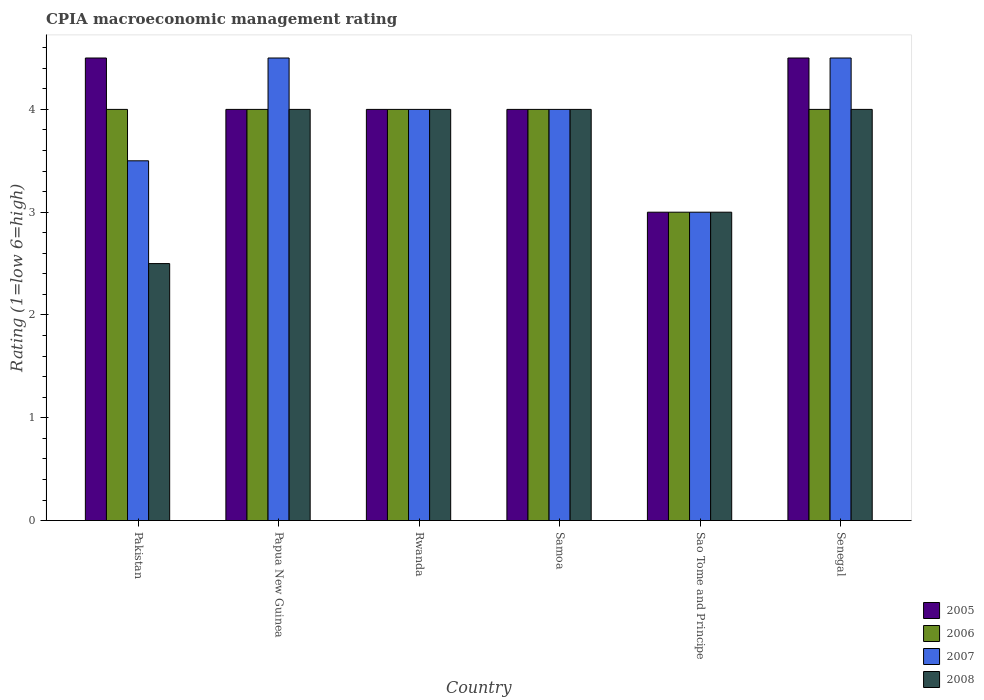Are the number of bars on each tick of the X-axis equal?
Provide a short and direct response. Yes. What is the label of the 4th group of bars from the left?
Your answer should be very brief. Samoa. In which country was the CPIA rating in 2008 maximum?
Ensure brevity in your answer.  Papua New Guinea. In which country was the CPIA rating in 2005 minimum?
Your answer should be compact. Sao Tome and Principe. What is the difference between the CPIA rating in 2005 in Rwanda and that in Senegal?
Keep it short and to the point. -0.5. What is the average CPIA rating in 2007 per country?
Offer a very short reply. 3.92. In how many countries, is the CPIA rating in 2007 greater than 3.2?
Your response must be concise. 5. What is the ratio of the CPIA rating in 2007 in Pakistan to that in Senegal?
Ensure brevity in your answer.  0.78. Is the difference between the CPIA rating in 2007 in Rwanda and Samoa greater than the difference between the CPIA rating in 2006 in Rwanda and Samoa?
Give a very brief answer. No. What is the difference between the highest and the second highest CPIA rating in 2005?
Provide a succinct answer. 0.5. What is the difference between the highest and the lowest CPIA rating in 2005?
Give a very brief answer. 1.5. In how many countries, is the CPIA rating in 2008 greater than the average CPIA rating in 2008 taken over all countries?
Your answer should be very brief. 4. Is it the case that in every country, the sum of the CPIA rating in 2005 and CPIA rating in 2008 is greater than the sum of CPIA rating in 2006 and CPIA rating in 2007?
Offer a terse response. No. What does the 3rd bar from the left in Rwanda represents?
Offer a terse response. 2007. Is it the case that in every country, the sum of the CPIA rating in 2006 and CPIA rating in 2007 is greater than the CPIA rating in 2005?
Offer a terse response. Yes. Are all the bars in the graph horizontal?
Your response must be concise. No. Does the graph contain grids?
Keep it short and to the point. No. How are the legend labels stacked?
Ensure brevity in your answer.  Vertical. What is the title of the graph?
Offer a terse response. CPIA macroeconomic management rating. Does "1985" appear as one of the legend labels in the graph?
Offer a terse response. No. What is the label or title of the X-axis?
Offer a very short reply. Country. What is the Rating (1=low 6=high) of 2006 in Pakistan?
Make the answer very short. 4. What is the Rating (1=low 6=high) in 2006 in Papua New Guinea?
Keep it short and to the point. 4. What is the Rating (1=low 6=high) of 2007 in Papua New Guinea?
Provide a short and direct response. 4.5. What is the Rating (1=low 6=high) in 2008 in Papua New Guinea?
Provide a short and direct response. 4. What is the Rating (1=low 6=high) of 2005 in Rwanda?
Your response must be concise. 4. What is the Rating (1=low 6=high) in 2008 in Rwanda?
Your response must be concise. 4. What is the Rating (1=low 6=high) of 2006 in Samoa?
Your response must be concise. 4. What is the Rating (1=low 6=high) of 2008 in Samoa?
Your response must be concise. 4. What is the Rating (1=low 6=high) in 2006 in Sao Tome and Principe?
Your response must be concise. 3. What is the Rating (1=low 6=high) of 2008 in Sao Tome and Principe?
Offer a terse response. 3. What is the Rating (1=low 6=high) in 2005 in Senegal?
Offer a terse response. 4.5. What is the Rating (1=low 6=high) in 2007 in Senegal?
Make the answer very short. 4.5. What is the Rating (1=low 6=high) of 2008 in Senegal?
Your answer should be compact. 4. Across all countries, what is the maximum Rating (1=low 6=high) in 2007?
Give a very brief answer. 4.5. Across all countries, what is the minimum Rating (1=low 6=high) of 2005?
Your answer should be compact. 3. Across all countries, what is the minimum Rating (1=low 6=high) of 2006?
Provide a short and direct response. 3. What is the total Rating (1=low 6=high) in 2006 in the graph?
Ensure brevity in your answer.  23. What is the total Rating (1=low 6=high) of 2007 in the graph?
Keep it short and to the point. 23.5. What is the total Rating (1=low 6=high) in 2008 in the graph?
Your response must be concise. 21.5. What is the difference between the Rating (1=low 6=high) in 2006 in Pakistan and that in Papua New Guinea?
Your answer should be compact. 0. What is the difference between the Rating (1=low 6=high) in 2007 in Pakistan and that in Papua New Guinea?
Your answer should be compact. -1. What is the difference between the Rating (1=low 6=high) in 2005 in Pakistan and that in Rwanda?
Provide a succinct answer. 0.5. What is the difference between the Rating (1=low 6=high) in 2005 in Pakistan and that in Samoa?
Ensure brevity in your answer.  0.5. What is the difference between the Rating (1=low 6=high) in 2007 in Pakistan and that in Samoa?
Offer a very short reply. -0.5. What is the difference between the Rating (1=low 6=high) of 2005 in Pakistan and that in Sao Tome and Principe?
Your answer should be compact. 1.5. What is the difference between the Rating (1=low 6=high) of 2007 in Pakistan and that in Sao Tome and Principe?
Your answer should be compact. 0.5. What is the difference between the Rating (1=low 6=high) of 2007 in Pakistan and that in Senegal?
Offer a terse response. -1. What is the difference between the Rating (1=low 6=high) in 2008 in Pakistan and that in Senegal?
Your answer should be very brief. -1.5. What is the difference between the Rating (1=low 6=high) in 2005 in Papua New Guinea and that in Rwanda?
Offer a terse response. 0. What is the difference between the Rating (1=low 6=high) of 2007 in Papua New Guinea and that in Rwanda?
Provide a short and direct response. 0.5. What is the difference between the Rating (1=low 6=high) of 2008 in Papua New Guinea and that in Rwanda?
Provide a short and direct response. 0. What is the difference between the Rating (1=low 6=high) of 2005 in Papua New Guinea and that in Samoa?
Make the answer very short. 0. What is the difference between the Rating (1=low 6=high) of 2006 in Papua New Guinea and that in Sao Tome and Principe?
Provide a succinct answer. 1. What is the difference between the Rating (1=low 6=high) of 2007 in Papua New Guinea and that in Sao Tome and Principe?
Your response must be concise. 1.5. What is the difference between the Rating (1=low 6=high) in 2008 in Papua New Guinea and that in Sao Tome and Principe?
Give a very brief answer. 1. What is the difference between the Rating (1=low 6=high) in 2006 in Papua New Guinea and that in Senegal?
Provide a succinct answer. 0. What is the difference between the Rating (1=low 6=high) in 2008 in Papua New Guinea and that in Senegal?
Your answer should be compact. 0. What is the difference between the Rating (1=low 6=high) in 2005 in Rwanda and that in Samoa?
Ensure brevity in your answer.  0. What is the difference between the Rating (1=low 6=high) of 2006 in Rwanda and that in Samoa?
Ensure brevity in your answer.  0. What is the difference between the Rating (1=low 6=high) of 2007 in Rwanda and that in Samoa?
Your answer should be very brief. 0. What is the difference between the Rating (1=low 6=high) of 2005 in Rwanda and that in Sao Tome and Principe?
Provide a short and direct response. 1. What is the difference between the Rating (1=low 6=high) in 2005 in Rwanda and that in Senegal?
Ensure brevity in your answer.  -0.5. What is the difference between the Rating (1=low 6=high) of 2007 in Rwanda and that in Senegal?
Give a very brief answer. -0.5. What is the difference between the Rating (1=low 6=high) in 2006 in Samoa and that in Sao Tome and Principe?
Give a very brief answer. 1. What is the difference between the Rating (1=low 6=high) of 2008 in Samoa and that in Sao Tome and Principe?
Offer a very short reply. 1. What is the difference between the Rating (1=low 6=high) in 2006 in Samoa and that in Senegal?
Your answer should be very brief. 0. What is the difference between the Rating (1=low 6=high) of 2007 in Samoa and that in Senegal?
Provide a short and direct response. -0.5. What is the difference between the Rating (1=low 6=high) of 2006 in Sao Tome and Principe and that in Senegal?
Offer a terse response. -1. What is the difference between the Rating (1=low 6=high) of 2007 in Sao Tome and Principe and that in Senegal?
Offer a very short reply. -1.5. What is the difference between the Rating (1=low 6=high) of 2005 in Pakistan and the Rating (1=low 6=high) of 2008 in Papua New Guinea?
Keep it short and to the point. 0.5. What is the difference between the Rating (1=low 6=high) of 2005 in Pakistan and the Rating (1=low 6=high) of 2008 in Rwanda?
Make the answer very short. 0.5. What is the difference between the Rating (1=low 6=high) of 2006 in Pakistan and the Rating (1=low 6=high) of 2007 in Rwanda?
Ensure brevity in your answer.  0. What is the difference between the Rating (1=low 6=high) in 2006 in Pakistan and the Rating (1=low 6=high) in 2008 in Rwanda?
Provide a short and direct response. 0. What is the difference between the Rating (1=low 6=high) in 2005 in Pakistan and the Rating (1=low 6=high) in 2006 in Samoa?
Make the answer very short. 0.5. What is the difference between the Rating (1=low 6=high) in 2006 in Pakistan and the Rating (1=low 6=high) in 2007 in Samoa?
Offer a terse response. 0. What is the difference between the Rating (1=low 6=high) of 2006 in Pakistan and the Rating (1=low 6=high) of 2008 in Samoa?
Provide a short and direct response. 0. What is the difference between the Rating (1=low 6=high) in 2007 in Pakistan and the Rating (1=low 6=high) in 2008 in Samoa?
Provide a succinct answer. -0.5. What is the difference between the Rating (1=low 6=high) of 2005 in Pakistan and the Rating (1=low 6=high) of 2007 in Sao Tome and Principe?
Your response must be concise. 1.5. What is the difference between the Rating (1=low 6=high) in 2006 in Pakistan and the Rating (1=low 6=high) in 2007 in Sao Tome and Principe?
Offer a terse response. 1. What is the difference between the Rating (1=low 6=high) of 2005 in Pakistan and the Rating (1=low 6=high) of 2006 in Senegal?
Your response must be concise. 0.5. What is the difference between the Rating (1=low 6=high) in 2005 in Pakistan and the Rating (1=low 6=high) in 2007 in Senegal?
Keep it short and to the point. 0. What is the difference between the Rating (1=low 6=high) of 2006 in Pakistan and the Rating (1=low 6=high) of 2007 in Senegal?
Ensure brevity in your answer.  -0.5. What is the difference between the Rating (1=low 6=high) in 2006 in Pakistan and the Rating (1=low 6=high) in 2008 in Senegal?
Keep it short and to the point. 0. What is the difference between the Rating (1=low 6=high) of 2005 in Papua New Guinea and the Rating (1=low 6=high) of 2007 in Rwanda?
Your answer should be compact. 0. What is the difference between the Rating (1=low 6=high) of 2007 in Papua New Guinea and the Rating (1=low 6=high) of 2008 in Rwanda?
Ensure brevity in your answer.  0.5. What is the difference between the Rating (1=low 6=high) in 2007 in Papua New Guinea and the Rating (1=low 6=high) in 2008 in Samoa?
Ensure brevity in your answer.  0.5. What is the difference between the Rating (1=low 6=high) in 2005 in Papua New Guinea and the Rating (1=low 6=high) in 2008 in Sao Tome and Principe?
Ensure brevity in your answer.  1. What is the difference between the Rating (1=low 6=high) in 2006 in Papua New Guinea and the Rating (1=low 6=high) in 2007 in Sao Tome and Principe?
Give a very brief answer. 1. What is the difference between the Rating (1=low 6=high) of 2006 in Papua New Guinea and the Rating (1=low 6=high) of 2008 in Sao Tome and Principe?
Keep it short and to the point. 1. What is the difference between the Rating (1=low 6=high) of 2007 in Papua New Guinea and the Rating (1=low 6=high) of 2008 in Sao Tome and Principe?
Offer a terse response. 1.5. What is the difference between the Rating (1=low 6=high) of 2005 in Papua New Guinea and the Rating (1=low 6=high) of 2006 in Senegal?
Offer a terse response. 0. What is the difference between the Rating (1=low 6=high) of 2005 in Papua New Guinea and the Rating (1=low 6=high) of 2008 in Senegal?
Ensure brevity in your answer.  0. What is the difference between the Rating (1=low 6=high) of 2007 in Papua New Guinea and the Rating (1=low 6=high) of 2008 in Senegal?
Offer a very short reply. 0.5. What is the difference between the Rating (1=low 6=high) of 2006 in Rwanda and the Rating (1=low 6=high) of 2007 in Samoa?
Provide a short and direct response. 0. What is the difference between the Rating (1=low 6=high) of 2006 in Rwanda and the Rating (1=low 6=high) of 2008 in Samoa?
Provide a succinct answer. 0. What is the difference between the Rating (1=low 6=high) in 2007 in Rwanda and the Rating (1=low 6=high) in 2008 in Samoa?
Ensure brevity in your answer.  0. What is the difference between the Rating (1=low 6=high) in 2005 in Rwanda and the Rating (1=low 6=high) in 2007 in Senegal?
Give a very brief answer. -0.5. What is the difference between the Rating (1=low 6=high) of 2005 in Rwanda and the Rating (1=low 6=high) of 2008 in Senegal?
Give a very brief answer. 0. What is the difference between the Rating (1=low 6=high) in 2006 in Rwanda and the Rating (1=low 6=high) in 2008 in Senegal?
Your answer should be compact. 0. What is the difference between the Rating (1=low 6=high) of 2007 in Rwanda and the Rating (1=low 6=high) of 2008 in Senegal?
Offer a very short reply. 0. What is the difference between the Rating (1=low 6=high) in 2005 in Samoa and the Rating (1=low 6=high) in 2006 in Sao Tome and Principe?
Offer a very short reply. 1. What is the difference between the Rating (1=low 6=high) in 2006 in Samoa and the Rating (1=low 6=high) in 2008 in Sao Tome and Principe?
Keep it short and to the point. 1. What is the difference between the Rating (1=low 6=high) of 2005 in Samoa and the Rating (1=low 6=high) of 2007 in Senegal?
Your answer should be compact. -0.5. What is the difference between the Rating (1=low 6=high) in 2006 in Samoa and the Rating (1=low 6=high) in 2008 in Senegal?
Your answer should be compact. 0. What is the difference between the Rating (1=low 6=high) in 2005 in Sao Tome and Principe and the Rating (1=low 6=high) in 2006 in Senegal?
Provide a succinct answer. -1. What is the difference between the Rating (1=low 6=high) in 2005 in Sao Tome and Principe and the Rating (1=low 6=high) in 2007 in Senegal?
Provide a short and direct response. -1.5. What is the difference between the Rating (1=low 6=high) in 2006 in Sao Tome and Principe and the Rating (1=low 6=high) in 2007 in Senegal?
Give a very brief answer. -1.5. What is the difference between the Rating (1=low 6=high) of 2006 in Sao Tome and Principe and the Rating (1=low 6=high) of 2008 in Senegal?
Your answer should be very brief. -1. What is the difference between the Rating (1=low 6=high) of 2007 in Sao Tome and Principe and the Rating (1=low 6=high) of 2008 in Senegal?
Offer a terse response. -1. What is the average Rating (1=low 6=high) of 2006 per country?
Your response must be concise. 3.83. What is the average Rating (1=low 6=high) of 2007 per country?
Your answer should be very brief. 3.92. What is the average Rating (1=low 6=high) in 2008 per country?
Offer a very short reply. 3.58. What is the difference between the Rating (1=low 6=high) of 2005 and Rating (1=low 6=high) of 2006 in Pakistan?
Provide a short and direct response. 0.5. What is the difference between the Rating (1=low 6=high) of 2006 and Rating (1=low 6=high) of 2007 in Pakistan?
Provide a short and direct response. 0.5. What is the difference between the Rating (1=low 6=high) in 2005 and Rating (1=low 6=high) in 2006 in Papua New Guinea?
Make the answer very short. 0. What is the difference between the Rating (1=low 6=high) of 2005 and Rating (1=low 6=high) of 2007 in Papua New Guinea?
Your answer should be compact. -0.5. What is the difference between the Rating (1=low 6=high) in 2006 and Rating (1=low 6=high) in 2007 in Papua New Guinea?
Your answer should be compact. -0.5. What is the difference between the Rating (1=low 6=high) of 2006 and Rating (1=low 6=high) of 2008 in Papua New Guinea?
Give a very brief answer. 0. What is the difference between the Rating (1=low 6=high) in 2005 and Rating (1=low 6=high) in 2006 in Rwanda?
Your answer should be very brief. 0. What is the difference between the Rating (1=low 6=high) in 2005 and Rating (1=low 6=high) in 2008 in Rwanda?
Ensure brevity in your answer.  0. What is the difference between the Rating (1=low 6=high) in 2006 and Rating (1=low 6=high) in 2007 in Rwanda?
Provide a succinct answer. 0. What is the difference between the Rating (1=low 6=high) in 2006 and Rating (1=low 6=high) in 2008 in Rwanda?
Keep it short and to the point. 0. What is the difference between the Rating (1=low 6=high) in 2005 and Rating (1=low 6=high) in 2006 in Samoa?
Your response must be concise. 0. What is the difference between the Rating (1=low 6=high) of 2005 and Rating (1=low 6=high) of 2007 in Samoa?
Keep it short and to the point. 0. What is the difference between the Rating (1=low 6=high) of 2005 and Rating (1=low 6=high) of 2007 in Sao Tome and Principe?
Ensure brevity in your answer.  0. What is the difference between the Rating (1=low 6=high) of 2006 and Rating (1=low 6=high) of 2008 in Sao Tome and Principe?
Make the answer very short. 0. What is the difference between the Rating (1=low 6=high) in 2005 and Rating (1=low 6=high) in 2006 in Senegal?
Give a very brief answer. 0.5. What is the difference between the Rating (1=low 6=high) in 2005 and Rating (1=low 6=high) in 2007 in Senegal?
Ensure brevity in your answer.  0. What is the difference between the Rating (1=low 6=high) of 2005 and Rating (1=low 6=high) of 2008 in Senegal?
Give a very brief answer. 0.5. What is the ratio of the Rating (1=low 6=high) of 2006 in Pakistan to that in Papua New Guinea?
Provide a short and direct response. 1. What is the ratio of the Rating (1=low 6=high) of 2005 in Pakistan to that in Rwanda?
Keep it short and to the point. 1.12. What is the ratio of the Rating (1=low 6=high) of 2006 in Pakistan to that in Rwanda?
Provide a succinct answer. 1. What is the ratio of the Rating (1=low 6=high) in 2007 in Pakistan to that in Rwanda?
Ensure brevity in your answer.  0.88. What is the ratio of the Rating (1=low 6=high) of 2008 in Pakistan to that in Rwanda?
Provide a short and direct response. 0.62. What is the ratio of the Rating (1=low 6=high) of 2005 in Pakistan to that in Samoa?
Provide a succinct answer. 1.12. What is the ratio of the Rating (1=low 6=high) of 2007 in Pakistan to that in Samoa?
Your answer should be compact. 0.88. What is the ratio of the Rating (1=low 6=high) in 2006 in Pakistan to that in Sao Tome and Principe?
Your answer should be very brief. 1.33. What is the ratio of the Rating (1=low 6=high) in 2007 in Pakistan to that in Sao Tome and Principe?
Your answer should be compact. 1.17. What is the ratio of the Rating (1=low 6=high) of 2008 in Pakistan to that in Sao Tome and Principe?
Make the answer very short. 0.83. What is the ratio of the Rating (1=low 6=high) in 2005 in Pakistan to that in Senegal?
Offer a very short reply. 1. What is the ratio of the Rating (1=low 6=high) of 2007 in Papua New Guinea to that in Rwanda?
Offer a terse response. 1.12. What is the ratio of the Rating (1=low 6=high) of 2005 in Papua New Guinea to that in Samoa?
Make the answer very short. 1. What is the ratio of the Rating (1=low 6=high) of 2007 in Papua New Guinea to that in Sao Tome and Principe?
Offer a very short reply. 1.5. What is the ratio of the Rating (1=low 6=high) of 2005 in Papua New Guinea to that in Senegal?
Provide a short and direct response. 0.89. What is the ratio of the Rating (1=low 6=high) in 2006 in Rwanda to that in Samoa?
Offer a very short reply. 1. What is the ratio of the Rating (1=low 6=high) in 2007 in Rwanda to that in Samoa?
Offer a very short reply. 1. What is the ratio of the Rating (1=low 6=high) of 2005 in Rwanda to that in Sao Tome and Principe?
Offer a terse response. 1.33. What is the ratio of the Rating (1=low 6=high) in 2006 in Rwanda to that in Sao Tome and Principe?
Ensure brevity in your answer.  1.33. What is the ratio of the Rating (1=low 6=high) of 2007 in Rwanda to that in Sao Tome and Principe?
Your response must be concise. 1.33. What is the ratio of the Rating (1=low 6=high) in 2008 in Rwanda to that in Sao Tome and Principe?
Your answer should be compact. 1.33. What is the ratio of the Rating (1=low 6=high) of 2005 in Rwanda to that in Senegal?
Provide a succinct answer. 0.89. What is the ratio of the Rating (1=low 6=high) of 2006 in Rwanda to that in Senegal?
Your response must be concise. 1. What is the ratio of the Rating (1=low 6=high) in 2008 in Rwanda to that in Senegal?
Your response must be concise. 1. What is the ratio of the Rating (1=low 6=high) in 2005 in Samoa to that in Sao Tome and Principe?
Your answer should be very brief. 1.33. What is the ratio of the Rating (1=low 6=high) of 2007 in Samoa to that in Sao Tome and Principe?
Give a very brief answer. 1.33. What is the ratio of the Rating (1=low 6=high) in 2005 in Samoa to that in Senegal?
Your response must be concise. 0.89. What is the ratio of the Rating (1=low 6=high) of 2007 in Samoa to that in Senegal?
Make the answer very short. 0.89. What is the ratio of the Rating (1=low 6=high) of 2008 in Samoa to that in Senegal?
Your response must be concise. 1. What is the ratio of the Rating (1=low 6=high) in 2005 in Sao Tome and Principe to that in Senegal?
Provide a succinct answer. 0.67. What is the ratio of the Rating (1=low 6=high) in 2007 in Sao Tome and Principe to that in Senegal?
Provide a short and direct response. 0.67. What is the difference between the highest and the second highest Rating (1=low 6=high) in 2006?
Offer a terse response. 0. What is the difference between the highest and the second highest Rating (1=low 6=high) in 2008?
Your response must be concise. 0. What is the difference between the highest and the lowest Rating (1=low 6=high) of 2005?
Your answer should be very brief. 1.5. 